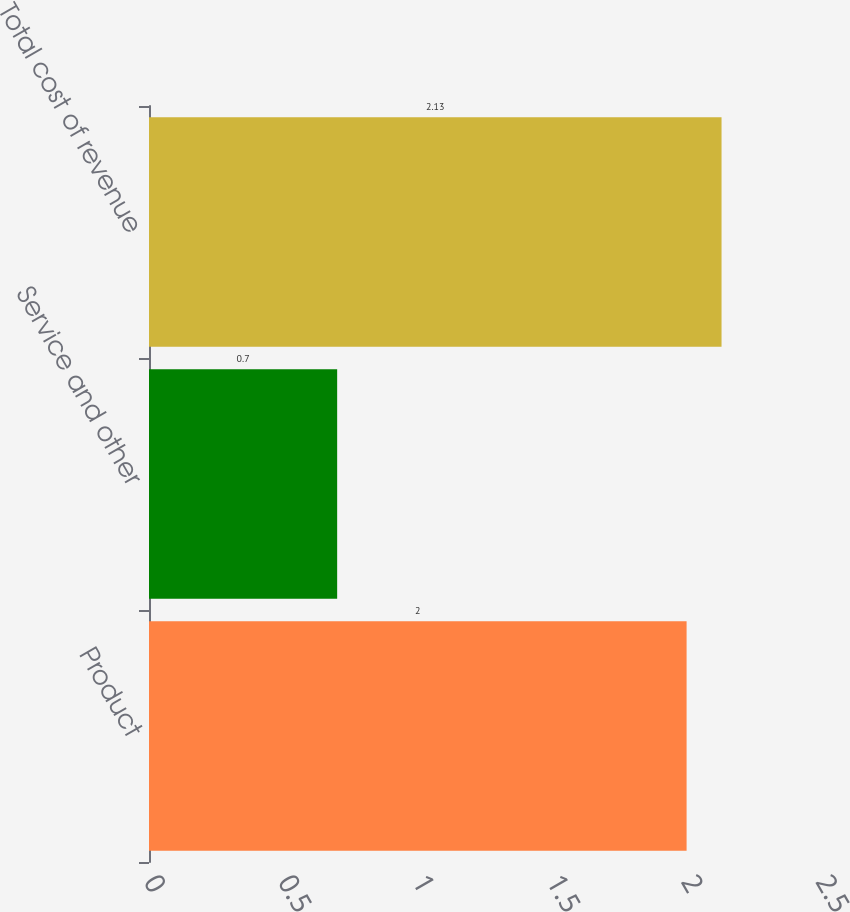<chart> <loc_0><loc_0><loc_500><loc_500><bar_chart><fcel>Product<fcel>Service and other<fcel>Total cost of revenue<nl><fcel>2<fcel>0.7<fcel>2.13<nl></chart> 